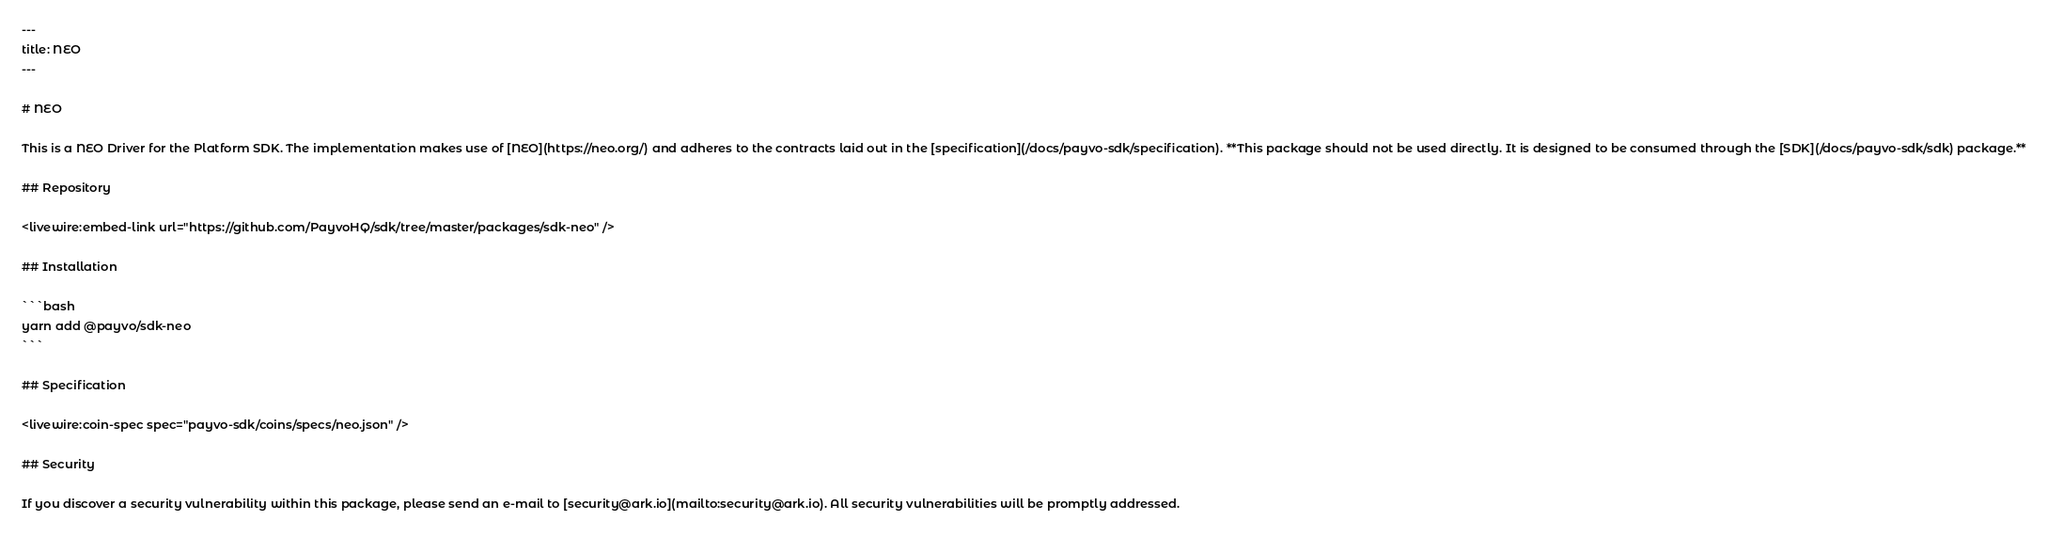<code> <loc_0><loc_0><loc_500><loc_500><_PHP_>---
title: NEO
---

# NEO

This is a NEO Driver for the Platform SDK. The implementation makes use of [NEO](https://neo.org/) and adheres to the contracts laid out in the [specification](/docs/payvo-sdk/specification). **This package should not be used directly. It is designed to be consumed through the [SDK](/docs/payvo-sdk/sdk) package.**

## Repository

<livewire:embed-link url="https://github.com/PayvoHQ/sdk/tree/master/packages/sdk-neo" />

## Installation

```bash
yarn add @payvo/sdk-neo
```

## Specification

<livewire:coin-spec spec="payvo-sdk/coins/specs/neo.json" />

## Security

If you discover a security vulnerability within this package, please send an e-mail to [security@ark.io](mailto:security@ark.io). All security vulnerabilities will be promptly addressed.
</code> 